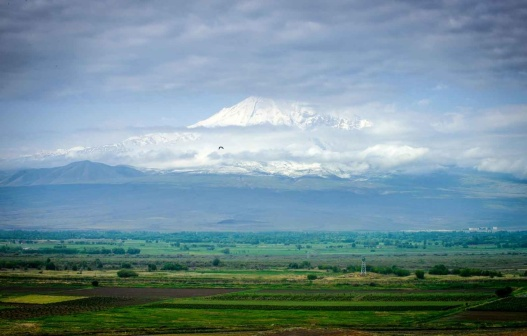Based on the image, can you craft a short story about a hidden village in this landscape? In the serene valley beneath the majestic mountain, there lies a hidden village untouched by time. Nestled between emerald fields and dense clusters of trees, the village of Elmswood thrives in harmony with nature. The villagers, known for their wisdom and gentle ways, live in quaint stone houses with thatched roofs. Every morning, the elders tell stories of the mystical mountain spirits to the children, filling their hearts with wonder. As the sun sets, casting a golden hue across the valley, the villagers gather to celebrate another day of peace and prosperity, their laughter blending with the songs of the evening birds. 